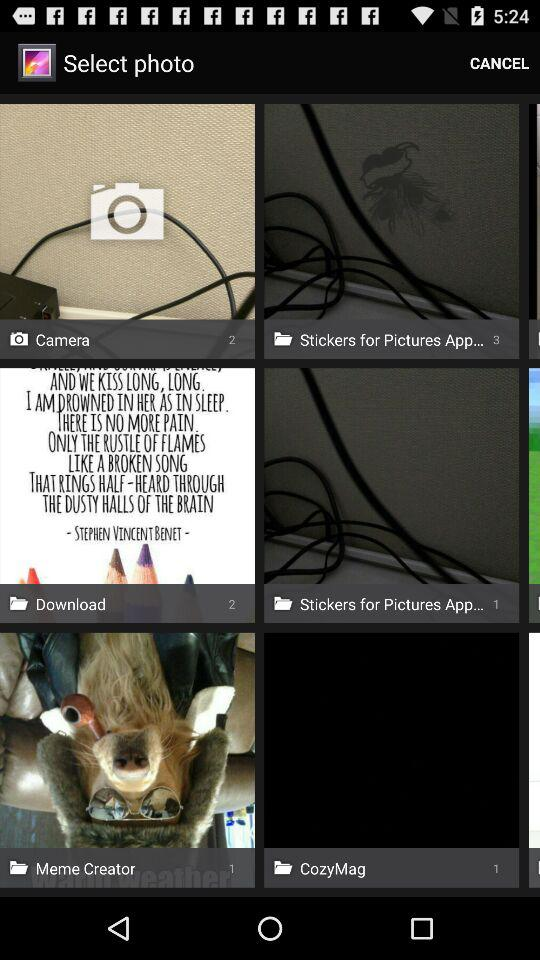How many photos are there in the "Camera" folder? There are 2 photos in the "Camera" folder. 